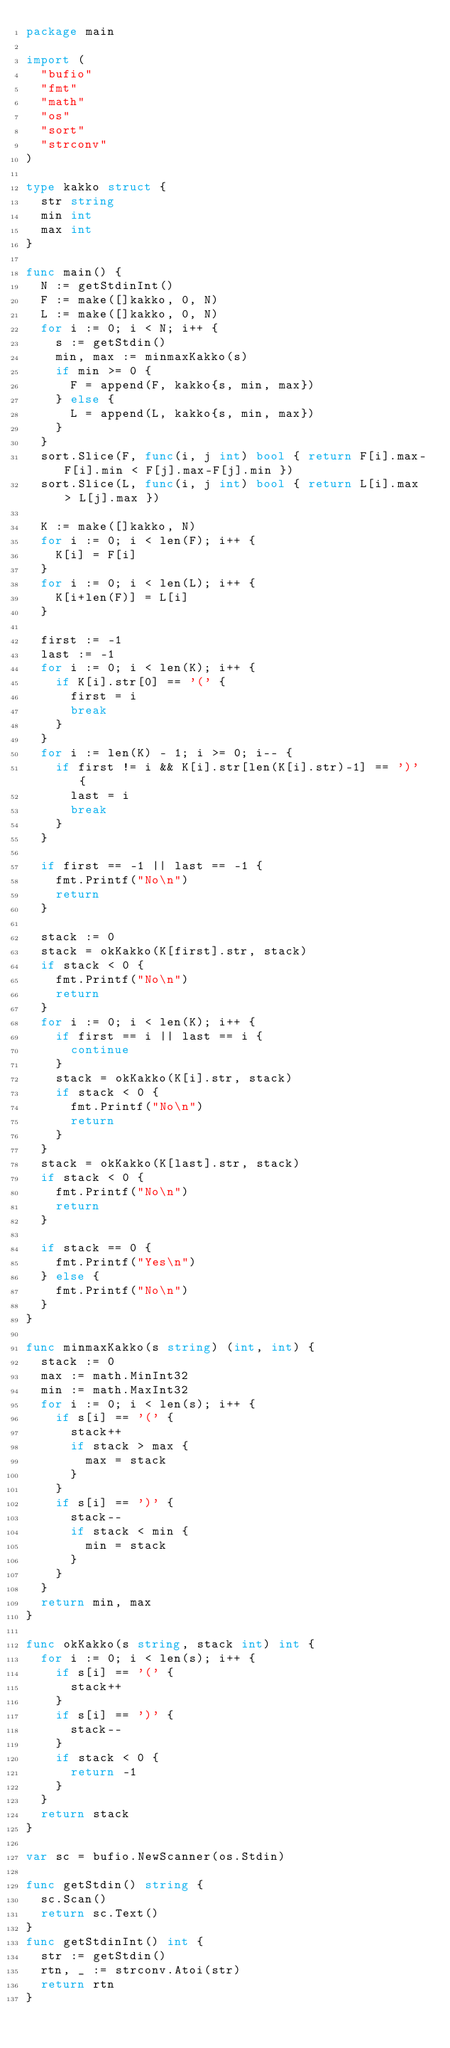Convert code to text. <code><loc_0><loc_0><loc_500><loc_500><_Go_>package main

import (
	"bufio"
	"fmt"
	"math"
	"os"
	"sort"
	"strconv"
)

type kakko struct {
	str string
	min int
	max int
}

func main() {
	N := getStdinInt()
	F := make([]kakko, 0, N)
	L := make([]kakko, 0, N)
	for i := 0; i < N; i++ {
		s := getStdin()
		min, max := minmaxKakko(s)
		if min >= 0 {
			F = append(F, kakko{s, min, max})
		} else {
			L = append(L, kakko{s, min, max})
		}
	}
	sort.Slice(F, func(i, j int) bool { return F[i].max-F[i].min < F[j].max-F[j].min })
	sort.Slice(L, func(i, j int) bool { return L[i].max > L[j].max })

	K := make([]kakko, N)
	for i := 0; i < len(F); i++ {
		K[i] = F[i]
	}
	for i := 0; i < len(L); i++ {
		K[i+len(F)] = L[i]
	}

	first := -1
	last := -1
	for i := 0; i < len(K); i++ {
		if K[i].str[0] == '(' {
			first = i
			break
		}
	}
	for i := len(K) - 1; i >= 0; i-- {
		if first != i && K[i].str[len(K[i].str)-1] == ')' {
			last = i
			break
		}
	}

	if first == -1 || last == -1 {
		fmt.Printf("No\n")
		return
	}

	stack := 0
	stack = okKakko(K[first].str, stack)
	if stack < 0 {
		fmt.Printf("No\n")
		return
	}
	for i := 0; i < len(K); i++ {
		if first == i || last == i {
			continue
		}
		stack = okKakko(K[i].str, stack)
		if stack < 0 {
			fmt.Printf("No\n")
			return
		}
	}
	stack = okKakko(K[last].str, stack)
	if stack < 0 {
		fmt.Printf("No\n")
		return
	}

	if stack == 0 {
		fmt.Printf("Yes\n")
	} else {
		fmt.Printf("No\n")
	}
}

func minmaxKakko(s string) (int, int) {
	stack := 0
	max := math.MinInt32
	min := math.MaxInt32
	for i := 0; i < len(s); i++ {
		if s[i] == '(' {
			stack++
			if stack > max {
				max = stack
			}
		}
		if s[i] == ')' {
			stack--
			if stack < min {
				min = stack
			}
		}
	}
	return min, max
}

func okKakko(s string, stack int) int {
	for i := 0; i < len(s); i++ {
		if s[i] == '(' {
			stack++
		}
		if s[i] == ')' {
			stack--
		}
		if stack < 0 {
			return -1
		}
	}
	return stack
}

var sc = bufio.NewScanner(os.Stdin)

func getStdin() string {
	sc.Scan()
	return sc.Text()
}
func getStdinInt() int {
	str := getStdin()
	rtn, _ := strconv.Atoi(str)
	return rtn
}
</code> 